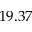Convert formula to latex. <formula><loc_0><loc_0><loc_500><loc_500>1 9 . 3 7</formula> 